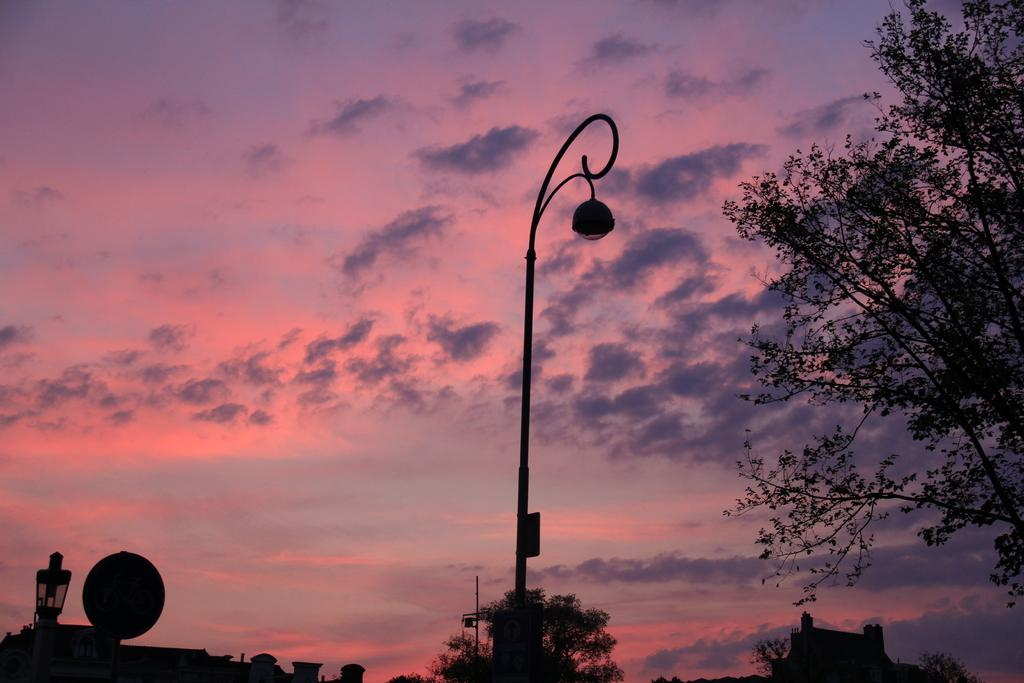What can be seen in the foreground of the image? In the foreground of the image, there are sign boards and poles, as well as a tree on the right side. What is visible in the background of the image? In the background of the image, there are trees, buildings, and the sky. Can you describe the sky in the image? The sky is visible in the background of the image, and there is a cloud present. What historical event is being commemorated by the eggs in the image? There are no eggs present in the image, so it is not possible to determine any historical event related to them. 